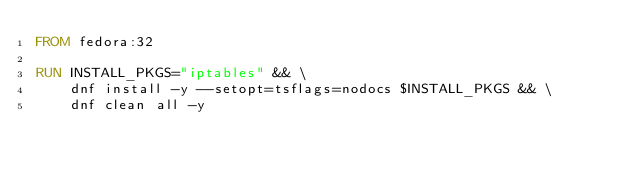<code> <loc_0><loc_0><loc_500><loc_500><_Dockerfile_>FROM fedora:32

RUN INSTALL_PKGS="iptables" && \
    dnf install -y --setopt=tsflags=nodocs $INSTALL_PKGS && \
    dnf clean all -y

</code> 